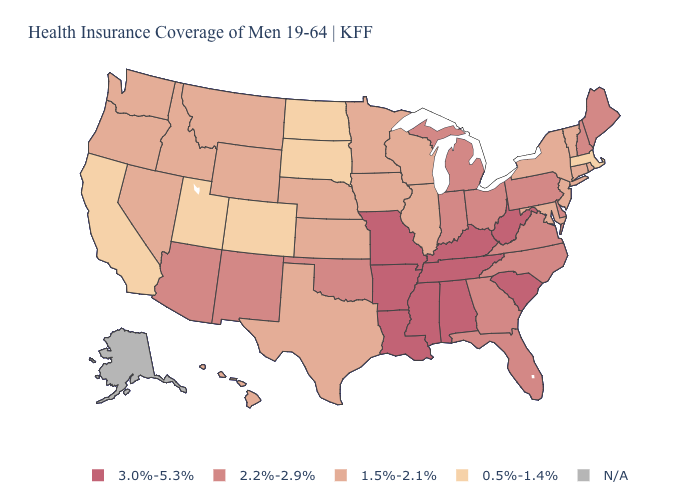Does the first symbol in the legend represent the smallest category?
Keep it brief. No. Among the states that border Maryland , which have the highest value?
Answer briefly. West Virginia. Among the states that border New York , does Pennsylvania have the highest value?
Be succinct. Yes. Does the first symbol in the legend represent the smallest category?
Answer briefly. No. Among the states that border South Dakota , which have the highest value?
Give a very brief answer. Iowa, Minnesota, Montana, Nebraska, Wyoming. Name the states that have a value in the range 2.2%-2.9%?
Answer briefly. Arizona, Delaware, Florida, Georgia, Indiana, Maine, Michigan, New Hampshire, New Mexico, North Carolina, Ohio, Oklahoma, Pennsylvania, Virginia. Does the map have missing data?
Keep it brief. Yes. Does Mississippi have the highest value in the USA?
Be succinct. Yes. Name the states that have a value in the range 2.2%-2.9%?
Give a very brief answer. Arizona, Delaware, Florida, Georgia, Indiana, Maine, Michigan, New Hampshire, New Mexico, North Carolina, Ohio, Oklahoma, Pennsylvania, Virginia. Name the states that have a value in the range 1.5%-2.1%?
Give a very brief answer. Connecticut, Hawaii, Idaho, Illinois, Iowa, Kansas, Maryland, Minnesota, Montana, Nebraska, Nevada, New Jersey, New York, Oregon, Rhode Island, Texas, Vermont, Washington, Wisconsin, Wyoming. What is the value of South Dakota?
Answer briefly. 0.5%-1.4%. What is the value of Texas?
Concise answer only. 1.5%-2.1%. Name the states that have a value in the range 0.5%-1.4%?
Concise answer only. California, Colorado, Massachusetts, North Dakota, South Dakota, Utah. Among the states that border Vermont , does New York have the lowest value?
Give a very brief answer. No. 